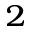<formula> <loc_0><loc_0><loc_500><loc_500>^ { 2 }</formula> 